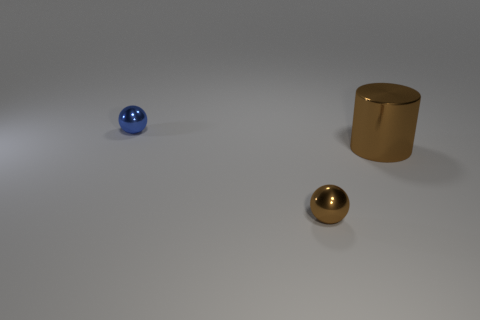Is there anything else of the same color as the big metallic thing?
Provide a short and direct response. Yes. Is the number of brown cylinders to the left of the large brown cylinder less than the number of cylinders?
Provide a short and direct response. Yes. Are there more small blue metallic balls than purple rubber spheres?
Give a very brief answer. Yes. There is a small metallic ball that is left of the shiny object that is in front of the big brown cylinder; are there any brown metallic balls that are behind it?
Your answer should be compact. No. How many other things are the same size as the metallic cylinder?
Ensure brevity in your answer.  0. There is a metallic cylinder; are there any large things in front of it?
Provide a short and direct response. No. There is a metallic cylinder; does it have the same color as the tiny object that is on the left side of the tiny brown sphere?
Your answer should be very brief. No. There is a tiny shiny object that is right of the tiny thing that is to the left of the shiny sphere in front of the large metal cylinder; what color is it?
Provide a succinct answer. Brown. Is there another tiny metal object of the same shape as the small brown object?
Your answer should be very brief. Yes. What is the color of the other shiny ball that is the same size as the brown metal ball?
Your answer should be compact. Blue. 